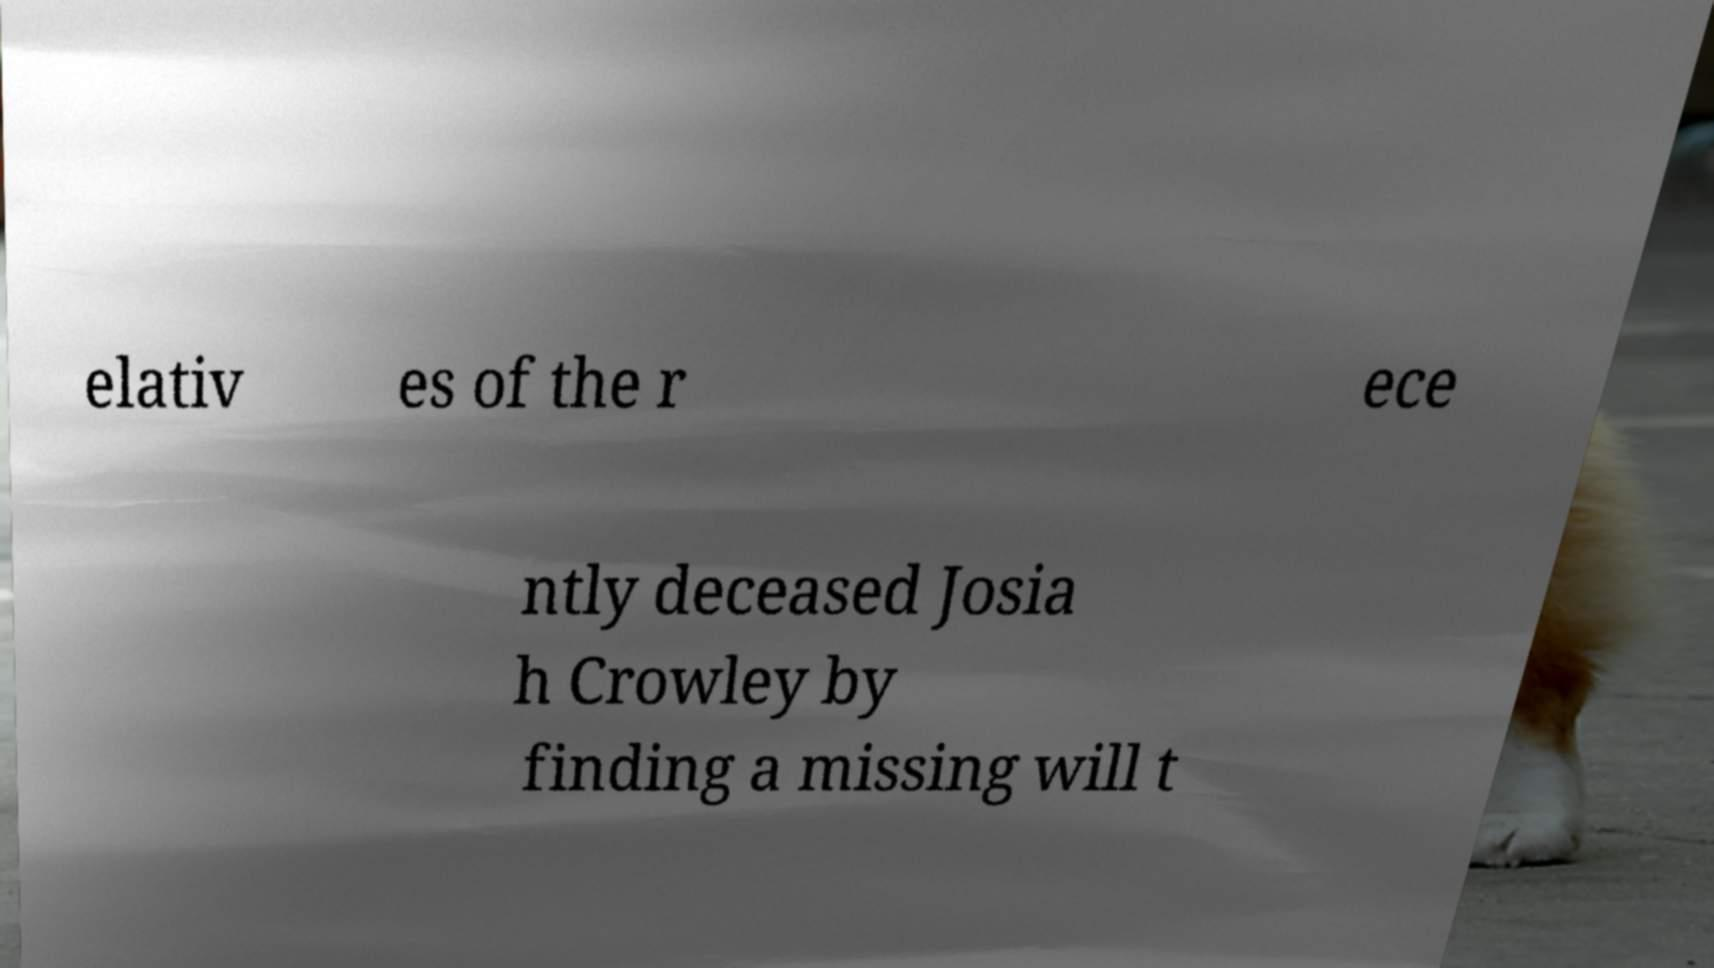Could you assist in decoding the text presented in this image and type it out clearly? elativ es of the r ece ntly deceased Josia h Crowley by finding a missing will t 